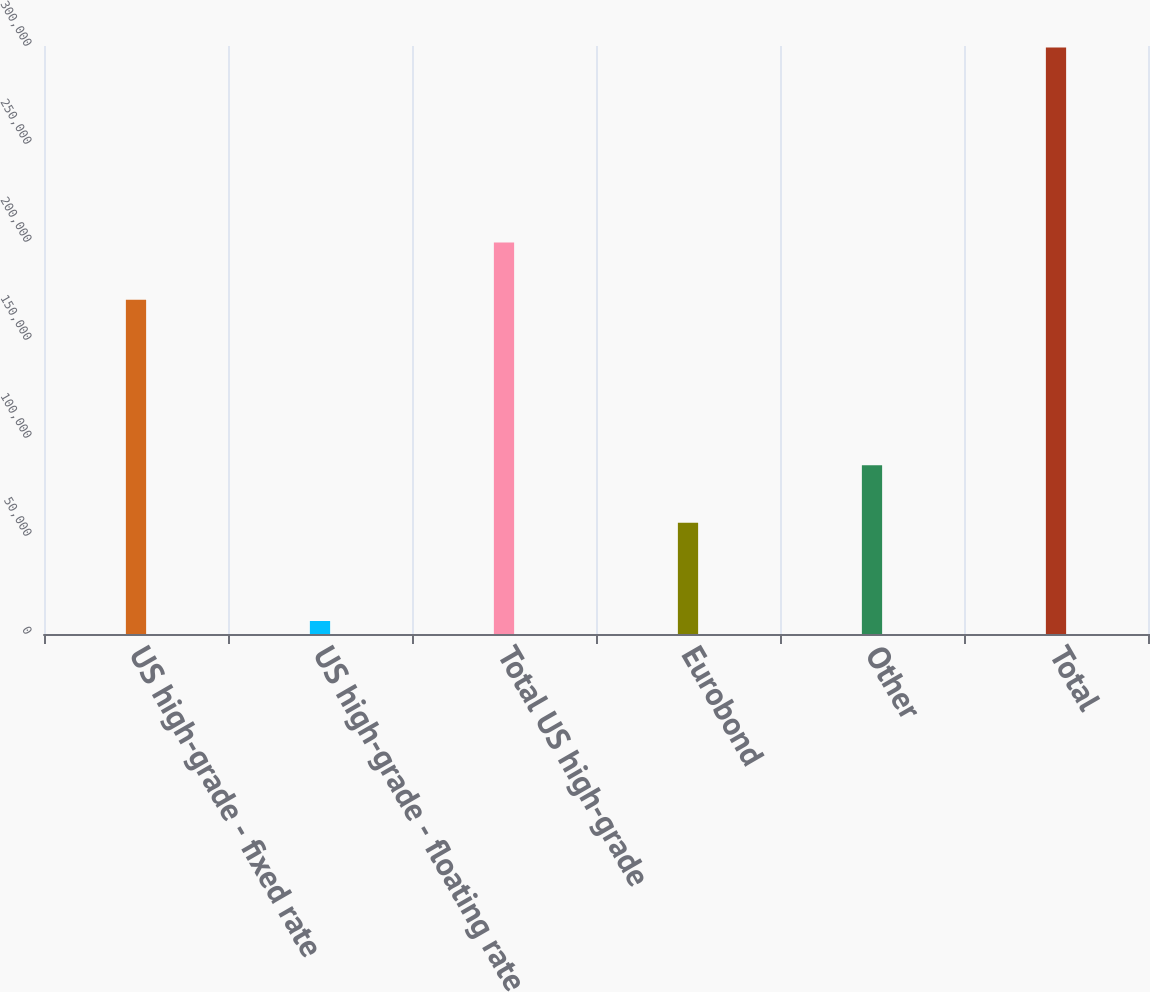Convert chart to OTSL. <chart><loc_0><loc_0><loc_500><loc_500><bar_chart><fcel>US high-grade - fixed rate<fcel>US high-grade - floating rate<fcel>Total US high-grade<fcel>Eurobond<fcel>Other<fcel>Total<nl><fcel>170519<fcel>6629<fcel>199785<fcel>56778<fcel>86043.7<fcel>299286<nl></chart> 